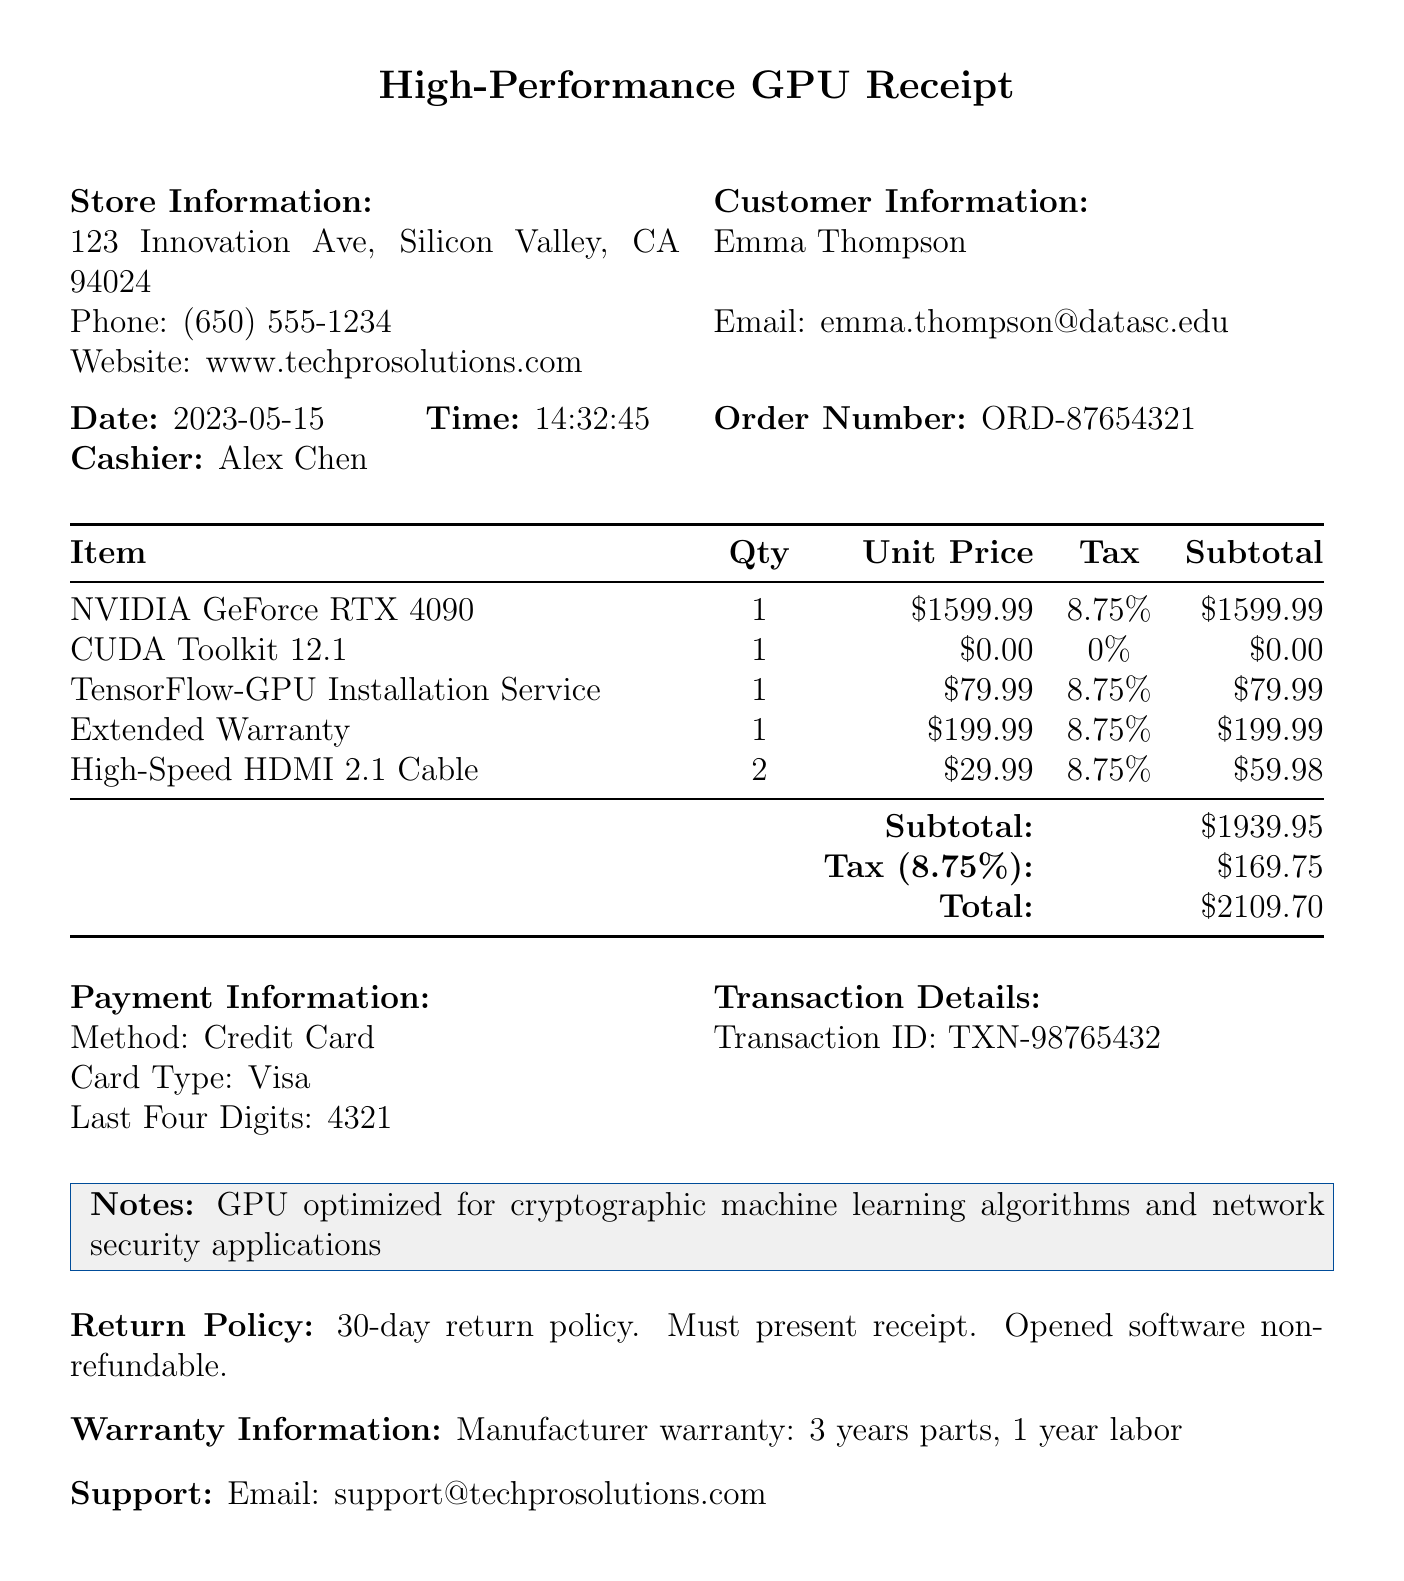What is the store name? The store name is mentioned at the top of the receipt, identifying the business where the purchase was made.
Answer: TechPro Solutions What is the date of purchase? The date of purchase is specified in the document, indicating when the transaction took place.
Answer: 2023-05-15 Who was the cashier? The cashier's name is listed in the receipt to identify who handled the transaction.
Answer: Alex Chen What is the quantity of the NVIDIA GeForce RTX 4090? The quantity of the NVIDIA GeForce RTX 4090 is noted in the itemized list, indicating how many units were bought.
Answer: 1 What is the total amount paid? The total amount paid is calculated from the subtotal and tax and is stated at the end of the receipt.
Answer: 2109.70 What was the purpose of the CUDA Toolkit? The description of the CUDA Toolkit explains its intended use or function relevant to the transaction.
Answer: Software development kit for NVIDIA GPUs What is the return policy? The return policy outlines the terms under which items can be returned and is mentioned near the bottom of the receipt.
Answer: 30-day return policy. Must present receipt. Opened software non-refundable What warranty is offered on the GPU? The warranty information describes the coverage provided for the GPU, giving details on parts and labor.
Answer: 3 years parts, 1 year labor What payment method was used? The payment method field clearly states how the transaction was completed.
Answer: Credit Card 